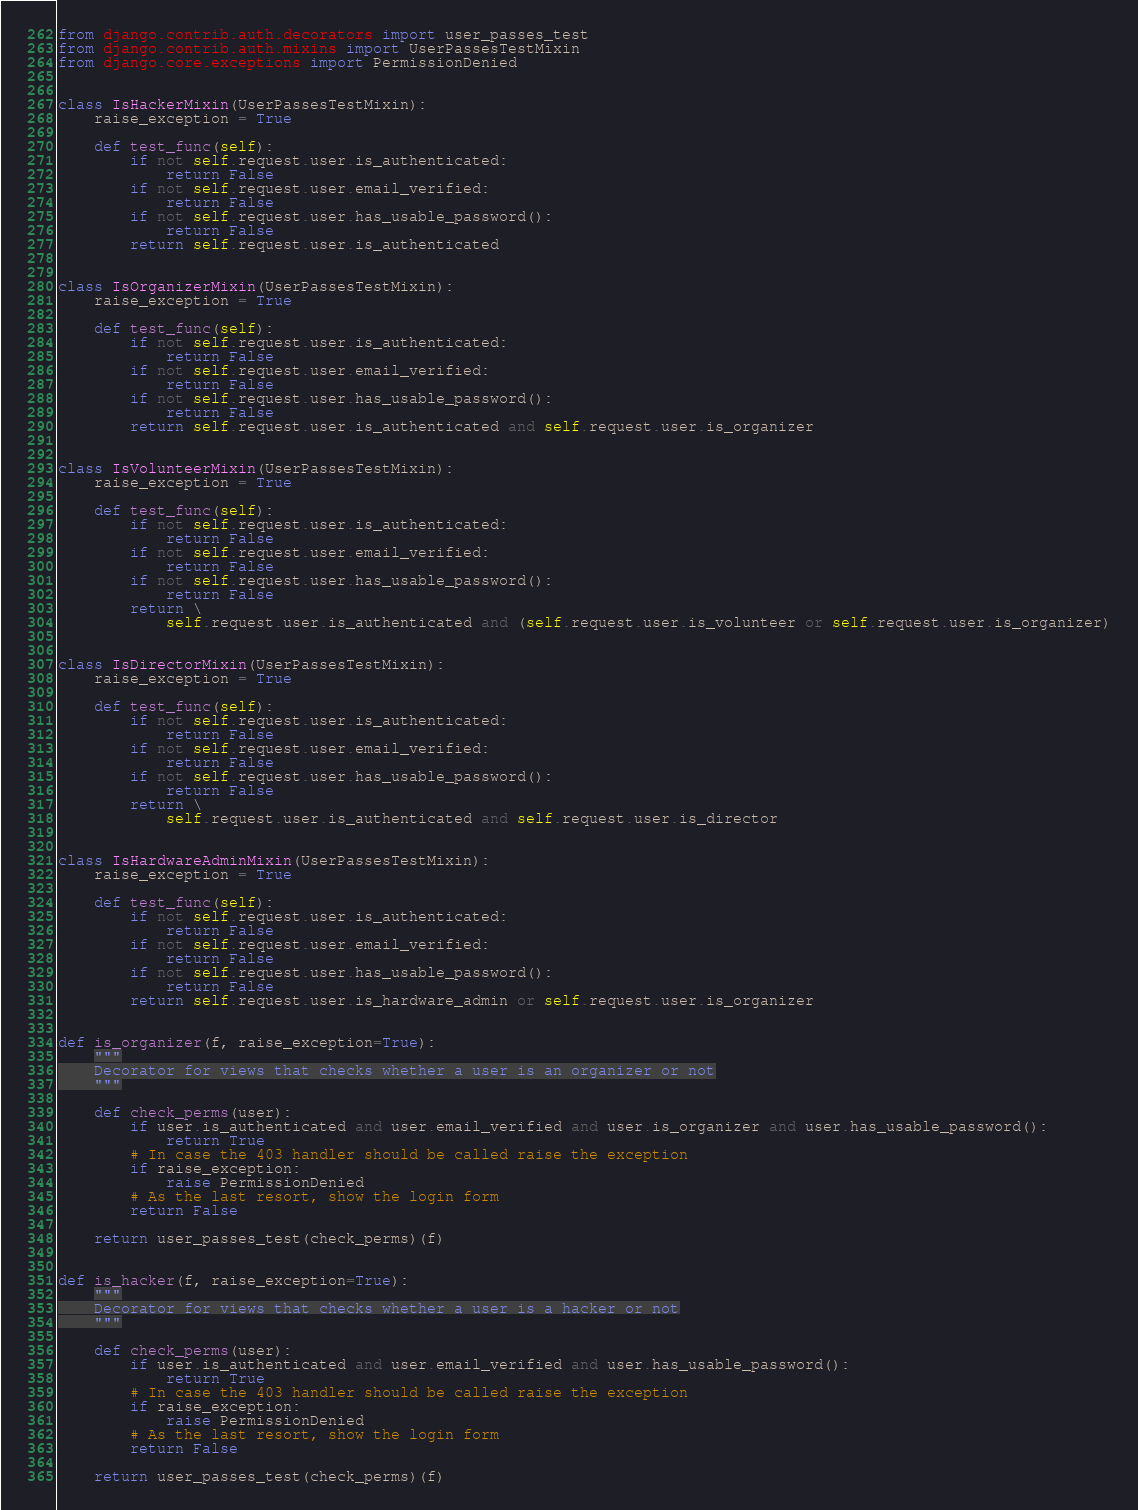<code> <loc_0><loc_0><loc_500><loc_500><_Python_>from django.contrib.auth.decorators import user_passes_test
from django.contrib.auth.mixins import UserPassesTestMixin
from django.core.exceptions import PermissionDenied


class IsHackerMixin(UserPassesTestMixin):
    raise_exception = True

    def test_func(self):
        if not self.request.user.is_authenticated:
            return False
        if not self.request.user.email_verified:
            return False
        if not self.request.user.has_usable_password():
            return False
        return self.request.user.is_authenticated


class IsOrganizerMixin(UserPassesTestMixin):
    raise_exception = True

    def test_func(self):
        if not self.request.user.is_authenticated:
            return False
        if not self.request.user.email_verified:
            return False
        if not self.request.user.has_usable_password():
            return False
        return self.request.user.is_authenticated and self.request.user.is_organizer


class IsVolunteerMixin(UserPassesTestMixin):
    raise_exception = True

    def test_func(self):
        if not self.request.user.is_authenticated:
            return False
        if not self.request.user.email_verified:
            return False
        if not self.request.user.has_usable_password():
            return False
        return \
            self.request.user.is_authenticated and (self.request.user.is_volunteer or self.request.user.is_organizer)


class IsDirectorMixin(UserPassesTestMixin):
    raise_exception = True

    def test_func(self):
        if not self.request.user.is_authenticated:
            return False
        if not self.request.user.email_verified:
            return False
        if not self.request.user.has_usable_password():
            return False
        return \
            self.request.user.is_authenticated and self.request.user.is_director


class IsHardwareAdminMixin(UserPassesTestMixin):
    raise_exception = True

    def test_func(self):
        if not self.request.user.is_authenticated:
            return False
        if not self.request.user.email_verified:
            return False
        if not self.request.user.has_usable_password():
            return False
        return self.request.user.is_hardware_admin or self.request.user.is_organizer


def is_organizer(f, raise_exception=True):
    """
    Decorator for views that checks whether a user is an organizer or not
    """

    def check_perms(user):
        if user.is_authenticated and user.email_verified and user.is_organizer and user.has_usable_password():
            return True
        # In case the 403 handler should be called raise the exception
        if raise_exception:
            raise PermissionDenied
        # As the last resort, show the login form
        return False

    return user_passes_test(check_perms)(f)


def is_hacker(f, raise_exception=True):
    """
    Decorator for views that checks whether a user is a hacker or not
    """

    def check_perms(user):
        if user.is_authenticated and user.email_verified and user.has_usable_password():
            return True
        # In case the 403 handler should be called raise the exception
        if raise_exception:
            raise PermissionDenied
        # As the last resort, show the login form
        return False

    return user_passes_test(check_perms)(f)
</code> 